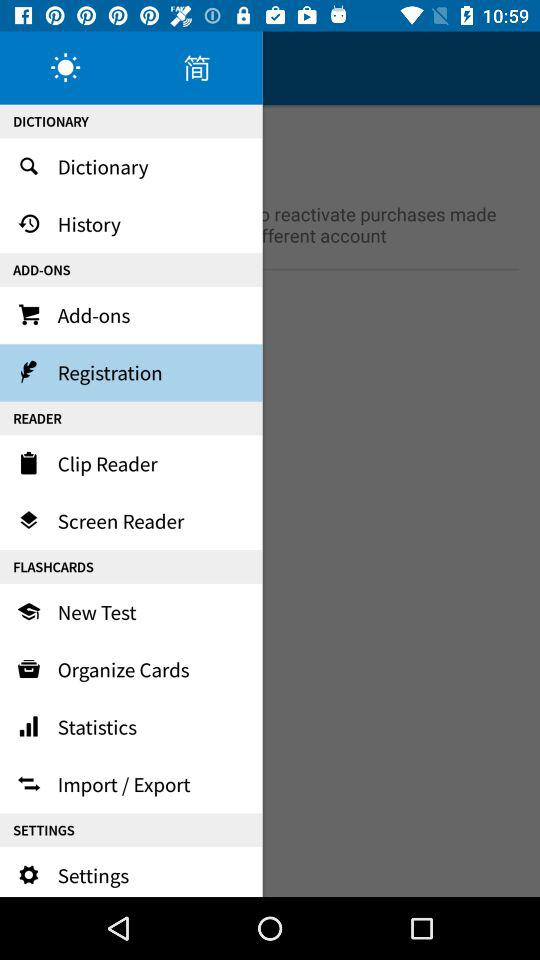How many items are in the Flashcards section?
Answer the question using a single word or phrase. 4 